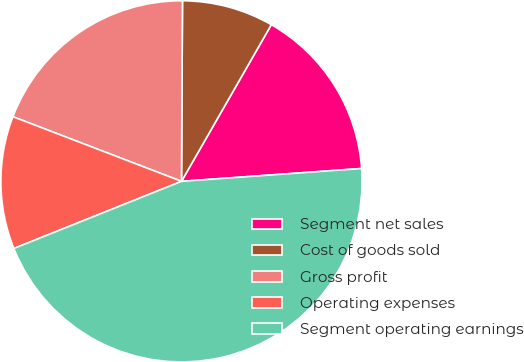<chart> <loc_0><loc_0><loc_500><loc_500><pie_chart><fcel>Segment net sales<fcel>Cost of goods sold<fcel>Gross profit<fcel>Operating expenses<fcel>Segment operating earnings<nl><fcel>15.58%<fcel>8.2%<fcel>19.26%<fcel>11.89%<fcel>45.07%<nl></chart> 